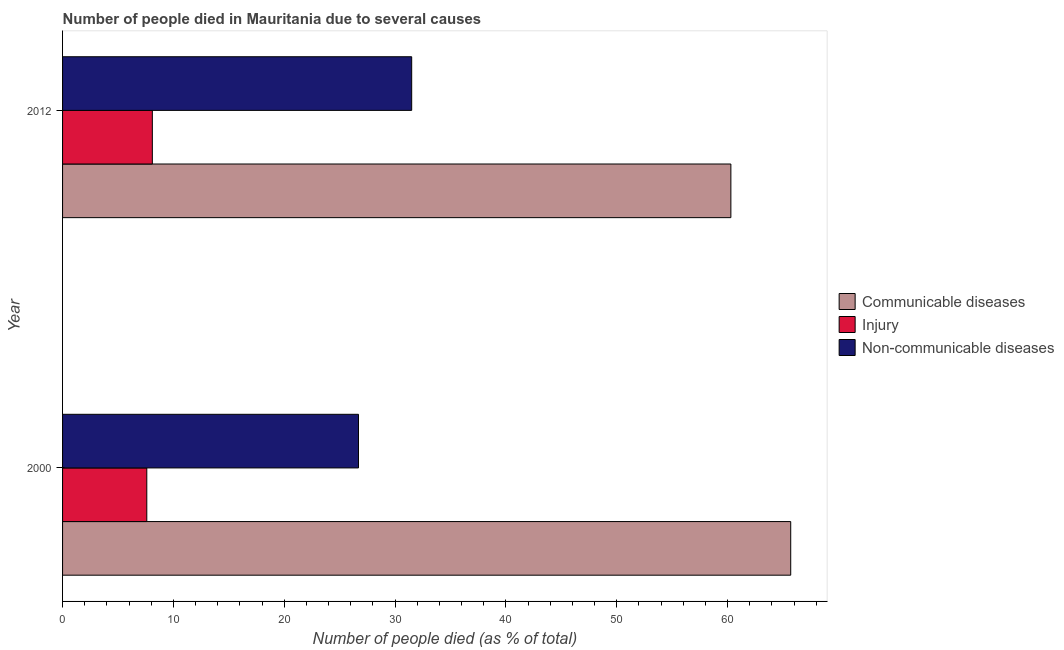How many groups of bars are there?
Your answer should be very brief. 2. Are the number of bars per tick equal to the number of legend labels?
Keep it short and to the point. Yes. Across all years, what is the maximum number of people who dies of non-communicable diseases?
Keep it short and to the point. 31.5. Across all years, what is the minimum number of people who died of communicable diseases?
Your answer should be very brief. 60.3. In which year was the number of people who died of injury maximum?
Make the answer very short. 2012. In which year was the number of people who dies of non-communicable diseases minimum?
Give a very brief answer. 2000. What is the total number of people who dies of non-communicable diseases in the graph?
Keep it short and to the point. 58.2. What is the difference between the number of people who died of injury in 2000 and that in 2012?
Offer a very short reply. -0.5. What is the difference between the number of people who dies of non-communicable diseases in 2000 and the number of people who died of injury in 2012?
Offer a very short reply. 18.6. In the year 2012, what is the difference between the number of people who dies of non-communicable diseases and number of people who died of communicable diseases?
Offer a terse response. -28.8. What is the ratio of the number of people who dies of non-communicable diseases in 2000 to that in 2012?
Ensure brevity in your answer.  0.85. Is the difference between the number of people who dies of non-communicable diseases in 2000 and 2012 greater than the difference between the number of people who died of injury in 2000 and 2012?
Your answer should be very brief. No. In how many years, is the number of people who dies of non-communicable diseases greater than the average number of people who dies of non-communicable diseases taken over all years?
Make the answer very short. 1. What does the 2nd bar from the top in 2000 represents?
Ensure brevity in your answer.  Injury. What does the 1st bar from the bottom in 2000 represents?
Give a very brief answer. Communicable diseases. How many bars are there?
Offer a very short reply. 6. Are all the bars in the graph horizontal?
Your answer should be compact. Yes. How many years are there in the graph?
Offer a very short reply. 2. Does the graph contain any zero values?
Give a very brief answer. No. How many legend labels are there?
Make the answer very short. 3. How are the legend labels stacked?
Your response must be concise. Vertical. What is the title of the graph?
Ensure brevity in your answer.  Number of people died in Mauritania due to several causes. What is the label or title of the X-axis?
Ensure brevity in your answer.  Number of people died (as % of total). What is the label or title of the Y-axis?
Your answer should be compact. Year. What is the Number of people died (as % of total) of Communicable diseases in 2000?
Offer a terse response. 65.7. What is the Number of people died (as % of total) in Injury in 2000?
Offer a terse response. 7.6. What is the Number of people died (as % of total) of Non-communicable diseases in 2000?
Provide a succinct answer. 26.7. What is the Number of people died (as % of total) of Communicable diseases in 2012?
Keep it short and to the point. 60.3. What is the Number of people died (as % of total) in Injury in 2012?
Ensure brevity in your answer.  8.1. What is the Number of people died (as % of total) of Non-communicable diseases in 2012?
Your answer should be very brief. 31.5. Across all years, what is the maximum Number of people died (as % of total) of Communicable diseases?
Make the answer very short. 65.7. Across all years, what is the maximum Number of people died (as % of total) in Non-communicable diseases?
Give a very brief answer. 31.5. Across all years, what is the minimum Number of people died (as % of total) of Communicable diseases?
Ensure brevity in your answer.  60.3. Across all years, what is the minimum Number of people died (as % of total) in Non-communicable diseases?
Keep it short and to the point. 26.7. What is the total Number of people died (as % of total) of Communicable diseases in the graph?
Provide a short and direct response. 126. What is the total Number of people died (as % of total) of Injury in the graph?
Your answer should be compact. 15.7. What is the total Number of people died (as % of total) in Non-communicable diseases in the graph?
Offer a very short reply. 58.2. What is the difference between the Number of people died (as % of total) of Injury in 2000 and that in 2012?
Offer a terse response. -0.5. What is the difference between the Number of people died (as % of total) of Non-communicable diseases in 2000 and that in 2012?
Make the answer very short. -4.8. What is the difference between the Number of people died (as % of total) of Communicable diseases in 2000 and the Number of people died (as % of total) of Injury in 2012?
Your answer should be compact. 57.6. What is the difference between the Number of people died (as % of total) of Communicable diseases in 2000 and the Number of people died (as % of total) of Non-communicable diseases in 2012?
Your answer should be very brief. 34.2. What is the difference between the Number of people died (as % of total) in Injury in 2000 and the Number of people died (as % of total) in Non-communicable diseases in 2012?
Ensure brevity in your answer.  -23.9. What is the average Number of people died (as % of total) of Injury per year?
Make the answer very short. 7.85. What is the average Number of people died (as % of total) of Non-communicable diseases per year?
Your answer should be compact. 29.1. In the year 2000, what is the difference between the Number of people died (as % of total) in Communicable diseases and Number of people died (as % of total) in Injury?
Offer a very short reply. 58.1. In the year 2000, what is the difference between the Number of people died (as % of total) in Injury and Number of people died (as % of total) in Non-communicable diseases?
Your response must be concise. -19.1. In the year 2012, what is the difference between the Number of people died (as % of total) of Communicable diseases and Number of people died (as % of total) of Injury?
Your answer should be very brief. 52.2. In the year 2012, what is the difference between the Number of people died (as % of total) in Communicable diseases and Number of people died (as % of total) in Non-communicable diseases?
Ensure brevity in your answer.  28.8. In the year 2012, what is the difference between the Number of people died (as % of total) in Injury and Number of people died (as % of total) in Non-communicable diseases?
Offer a terse response. -23.4. What is the ratio of the Number of people died (as % of total) in Communicable diseases in 2000 to that in 2012?
Ensure brevity in your answer.  1.09. What is the ratio of the Number of people died (as % of total) in Injury in 2000 to that in 2012?
Ensure brevity in your answer.  0.94. What is the ratio of the Number of people died (as % of total) of Non-communicable diseases in 2000 to that in 2012?
Your response must be concise. 0.85. What is the difference between the highest and the second highest Number of people died (as % of total) of Communicable diseases?
Offer a very short reply. 5.4. What is the difference between the highest and the lowest Number of people died (as % of total) of Communicable diseases?
Your response must be concise. 5.4. What is the difference between the highest and the lowest Number of people died (as % of total) in Injury?
Ensure brevity in your answer.  0.5. What is the difference between the highest and the lowest Number of people died (as % of total) of Non-communicable diseases?
Offer a very short reply. 4.8. 